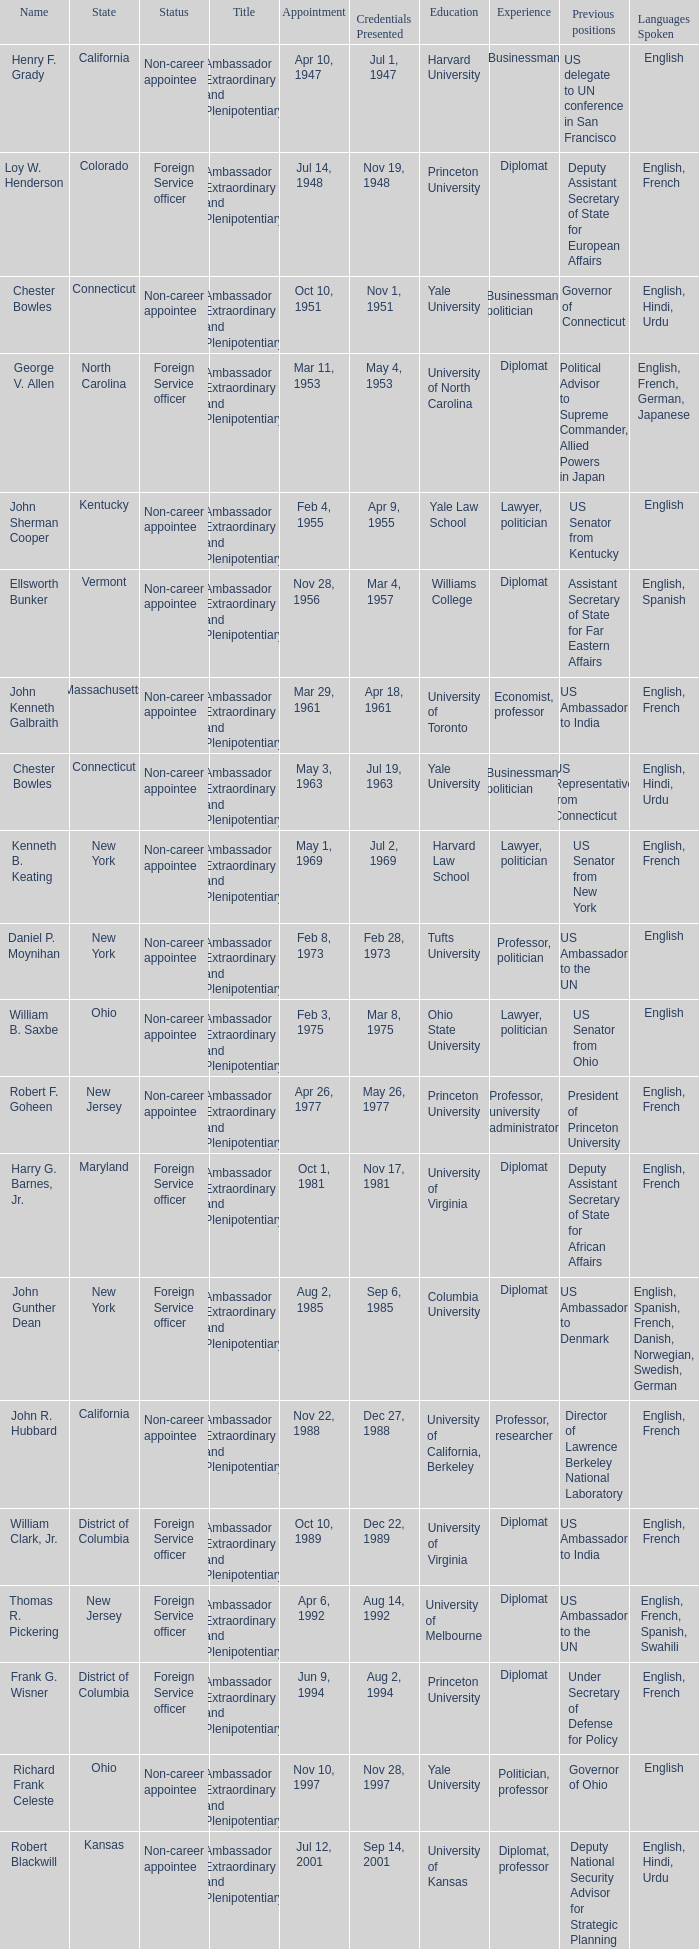What day was the appointment when Credentials Presented was jul 2, 1969? May 1, 1969. I'm looking to parse the entire table for insights. Could you assist me with that? {'header': ['Name', 'State', 'Status', 'Title', 'Appointment', 'Credentials Presented', 'Education', 'Experience', 'Previous positions', 'Languages Spoken'], 'rows': [['Henry F. Grady', 'California', 'Non-career appointee', 'Ambassador Extraordinary and Plenipotentiary', 'Apr 10, 1947', 'Jul 1, 1947', 'Harvard University', 'Businessman', 'US delegate to UN conference in San Francisco', 'English'], ['Loy W. Henderson', 'Colorado', 'Foreign Service officer', 'Ambassador Extraordinary and Plenipotentiary', 'Jul 14, 1948', 'Nov 19, 1948', 'Princeton University', 'Diplomat', 'Deputy Assistant Secretary of State for European Affairs', 'English, French'], ['Chester Bowles', 'Connecticut', 'Non-career appointee', 'Ambassador Extraordinary and Plenipotentiary', 'Oct 10, 1951', 'Nov 1, 1951', 'Yale University', 'Businessman, politician', 'Governor of Connecticut', 'English, Hindi, Urdu'], ['George V. Allen', 'North Carolina', 'Foreign Service officer', 'Ambassador Extraordinary and Plenipotentiary', 'Mar 11, 1953', 'May 4, 1953', 'University of North Carolina', 'Diplomat', 'Political Advisor to Supreme Commander, Allied Powers in Japan', 'English, French, German, Japanese'], ['John Sherman Cooper', 'Kentucky', 'Non-career appointee', 'Ambassador Extraordinary and Plenipotentiary', 'Feb 4, 1955', 'Apr 9, 1955', 'Yale Law School', 'Lawyer, politician', 'US Senator from Kentucky', 'English'], ['Ellsworth Bunker', 'Vermont', 'Non-career appointee', 'Ambassador Extraordinary and Plenipotentiary', 'Nov 28, 1956', 'Mar 4, 1957', 'Williams College', 'Diplomat', 'Assistant Secretary of State for Far Eastern Affairs', 'English, Spanish'], ['John Kenneth Galbraith', 'Massachusetts', 'Non-career appointee', 'Ambassador Extraordinary and Plenipotentiary', 'Mar 29, 1961', 'Apr 18, 1961', 'University of Toronto', 'Economist, professor', 'US Ambassador to India', 'English, French'], ['Chester Bowles', 'Connecticut', 'Non-career appointee', 'Ambassador Extraordinary and Plenipotentiary', 'May 3, 1963', 'Jul 19, 1963', 'Yale University', 'Businessman, politician', 'US Representative from Connecticut', 'English, Hindi, Urdu'], ['Kenneth B. Keating', 'New York', 'Non-career appointee', 'Ambassador Extraordinary and Plenipotentiary', 'May 1, 1969', 'Jul 2, 1969', 'Harvard Law School', 'Lawyer, politician', 'US Senator from New York', 'English, French'], ['Daniel P. Moynihan', 'New York', 'Non-career appointee', 'Ambassador Extraordinary and Plenipotentiary', 'Feb 8, 1973', 'Feb 28, 1973', 'Tufts University', 'Professor, politician', 'US Ambassador to the UN', 'English'], ['William B. Saxbe', 'Ohio', 'Non-career appointee', 'Ambassador Extraordinary and Plenipotentiary', 'Feb 3, 1975', 'Mar 8, 1975', 'Ohio State University', 'Lawyer, politician', 'US Senator from Ohio', 'English'], ['Robert F. Goheen', 'New Jersey', 'Non-career appointee', 'Ambassador Extraordinary and Plenipotentiary', 'Apr 26, 1977', 'May 26, 1977', 'Princeton University', 'Professor, university administrator', 'President of Princeton University', 'English, French'], ['Harry G. Barnes, Jr.', 'Maryland', 'Foreign Service officer', 'Ambassador Extraordinary and Plenipotentiary', 'Oct 1, 1981', 'Nov 17, 1981', 'University of Virginia', 'Diplomat', 'Deputy Assistant Secretary of State for African Affairs', 'English, French'], ['John Gunther Dean', 'New York', 'Foreign Service officer', 'Ambassador Extraordinary and Plenipotentiary', 'Aug 2, 1985', 'Sep 6, 1985', 'Columbia University', 'Diplomat', 'US Ambassador to Denmark', 'English, Spanish, French, Danish, Norwegian, Swedish, German'], ['John R. Hubbard', 'California', 'Non-career appointee', 'Ambassador Extraordinary and Plenipotentiary', 'Nov 22, 1988', 'Dec 27, 1988', 'University of California, Berkeley', 'Professor, researcher', 'Director of Lawrence Berkeley National Laboratory', 'English, French'], ['William Clark, Jr.', 'District of Columbia', 'Foreign Service officer', 'Ambassador Extraordinary and Plenipotentiary', 'Oct 10, 1989', 'Dec 22, 1989', 'University of Virginia', 'Diplomat', 'US Ambassador to India', 'English, French'], ['Thomas R. Pickering', 'New Jersey', 'Foreign Service officer', 'Ambassador Extraordinary and Plenipotentiary', 'Apr 6, 1992', 'Aug 14, 1992', 'University of Melbourne', 'Diplomat', 'US Ambassador to the UN', 'English, French, Spanish, Swahili'], ['Frank G. Wisner', 'District of Columbia', 'Foreign Service officer', 'Ambassador Extraordinary and Plenipotentiary', 'Jun 9, 1994', 'Aug 2, 1994', 'Princeton University', 'Diplomat', 'Under Secretary of Defense for Policy', 'English, French'], ['Richard Frank Celeste', 'Ohio', 'Non-career appointee', 'Ambassador Extraordinary and Plenipotentiary', 'Nov 10, 1997', 'Nov 28, 1997', 'Yale University', 'Politician, professor', 'Governor of Ohio', 'English'], ['Robert Blackwill', 'Kansas', 'Non-career appointee', 'Ambassador Extraordinary and Plenipotentiary', 'Jul 12, 2001', 'Sep 14, 2001', 'University of Kansas', 'Diplomat, professor', 'Deputy National Security Advisor for Strategic Planning', 'English, Hindi, Urdu'], ['David Campbell Mulford', 'Illinois', 'Non-career officer', 'Ambassador Extraordinary and Plenipotentiary', 'Dec 12, 2003', 'Feb 23, 2004', 'Northwestern University', 'Banker', 'Vice Chairman of Credit Suisse First Boston', 'English'], ['Timothy J. Roemer', 'Indiana', 'Non-career appointee', 'Ambassador Extraordinary and Plenipotentiary', 'Jul 23, 2009', 'Aug 11, 2009', 'University of California, Berkeley', 'Politician, professor', 'US Representative from Indiana', 'English'], ['Albert Peter Burleigh', 'California', 'Foreign Service officer', "Charge d'affaires", 'June 2011', 'Left post 2012', 'University of California, Berkeley', 'Diplomat', 'Deputy Chief of Mission, US Embassy, New Delhi', 'English, Hindi'], ['Nancy Jo Powell', 'Iowa', 'Foreign Service officer', 'Ambassador Extraordinary and Plenipotentiary', 'February 7, 2012', 'April 19, 2012', 'University of Northern Iowa', 'Diplomat', 'US Ambassador to Nepal', 'English, Gujarati, French']]} 